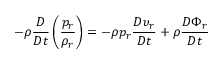Convert formula to latex. <formula><loc_0><loc_0><loc_500><loc_500>- \rho \frac { D } { D t } \left ( \frac { p _ { r } } { \rho _ { r } } \right ) = - \rho p _ { r } \frac { D \upsilon _ { r } } { D t } + \rho \frac { D \Phi _ { r } } { D t }</formula> 